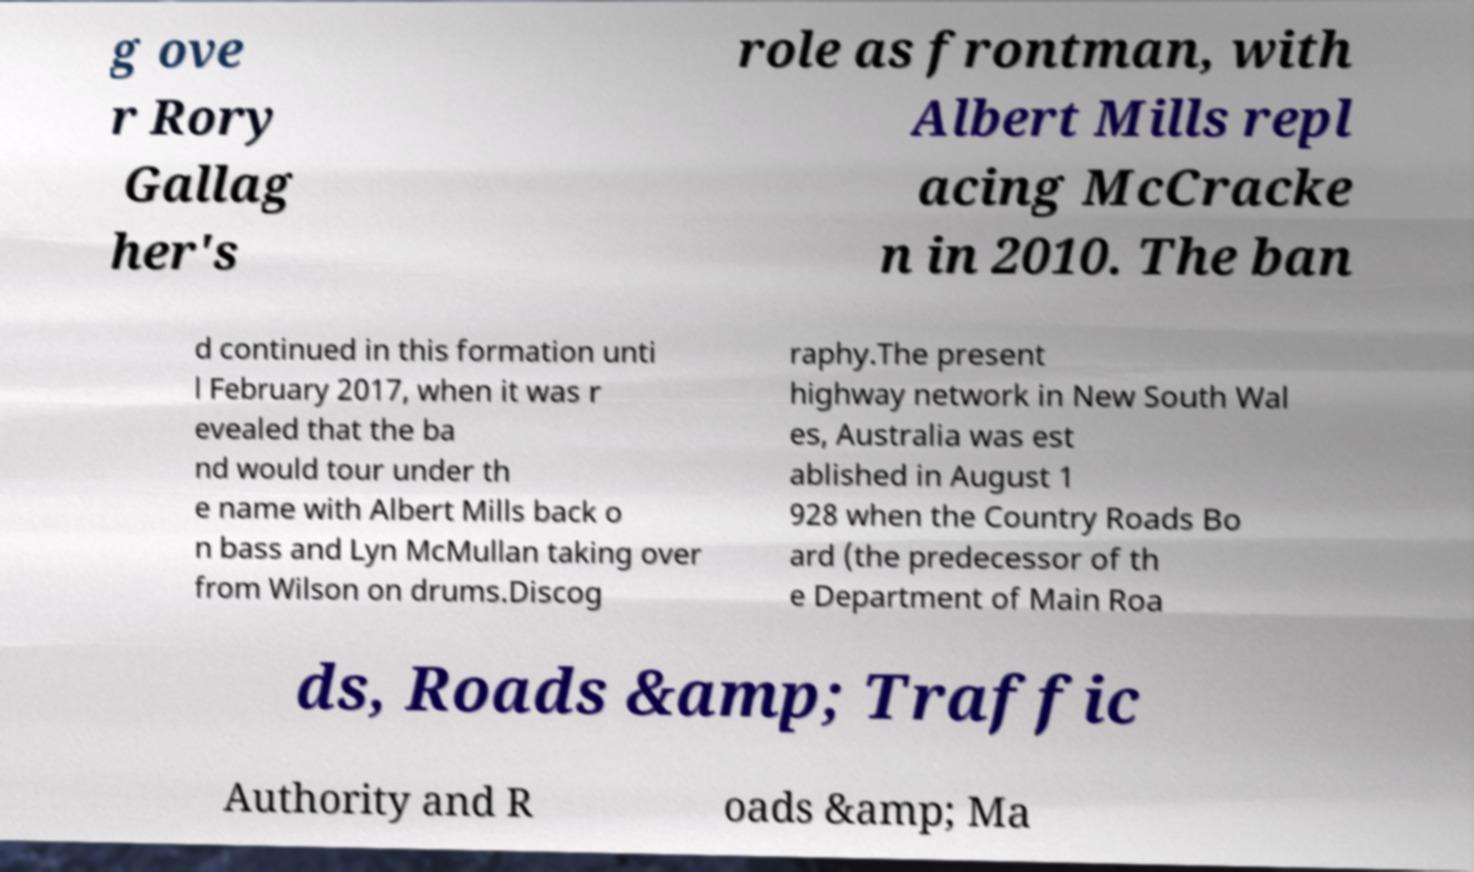Can you read and provide the text displayed in the image?This photo seems to have some interesting text. Can you extract and type it out for me? g ove r Rory Gallag her's role as frontman, with Albert Mills repl acing McCracke n in 2010. The ban d continued in this formation unti l February 2017, when it was r evealed that the ba nd would tour under th e name with Albert Mills back o n bass and Lyn McMullan taking over from Wilson on drums.Discog raphy.The present highway network in New South Wal es, Australia was est ablished in August 1 928 when the Country Roads Bo ard (the predecessor of th e Department of Main Roa ds, Roads &amp; Traffic Authority and R oads &amp; Ma 